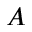<formula> <loc_0><loc_0><loc_500><loc_500>A</formula> 